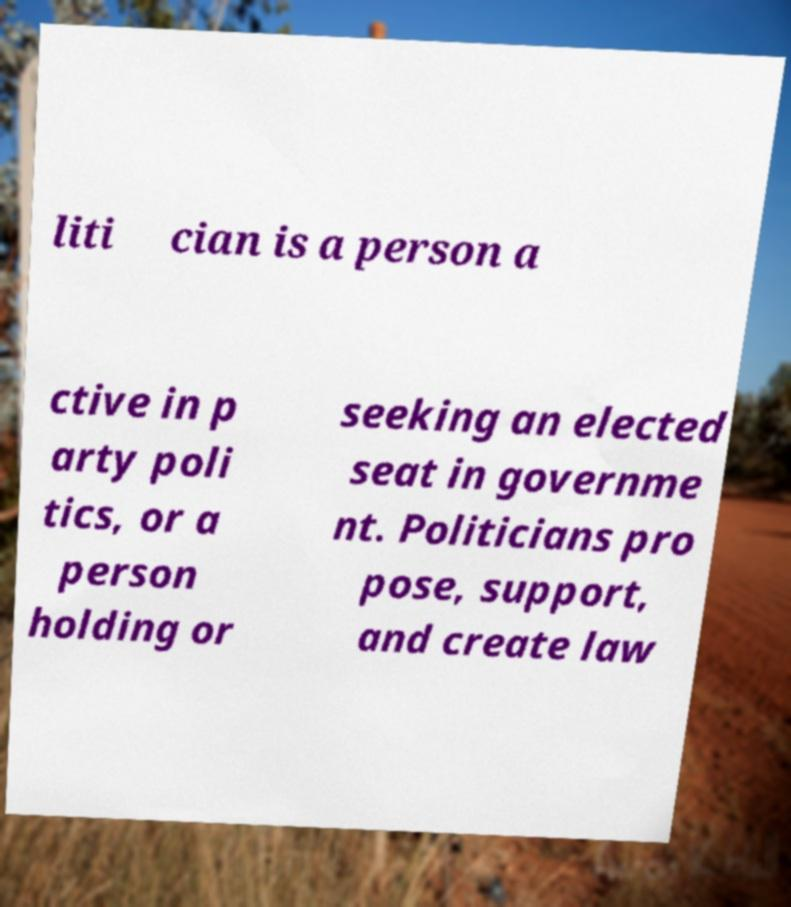Could you extract and type out the text from this image? liti cian is a person a ctive in p arty poli tics, or a person holding or seeking an elected seat in governme nt. Politicians pro pose, support, and create law 